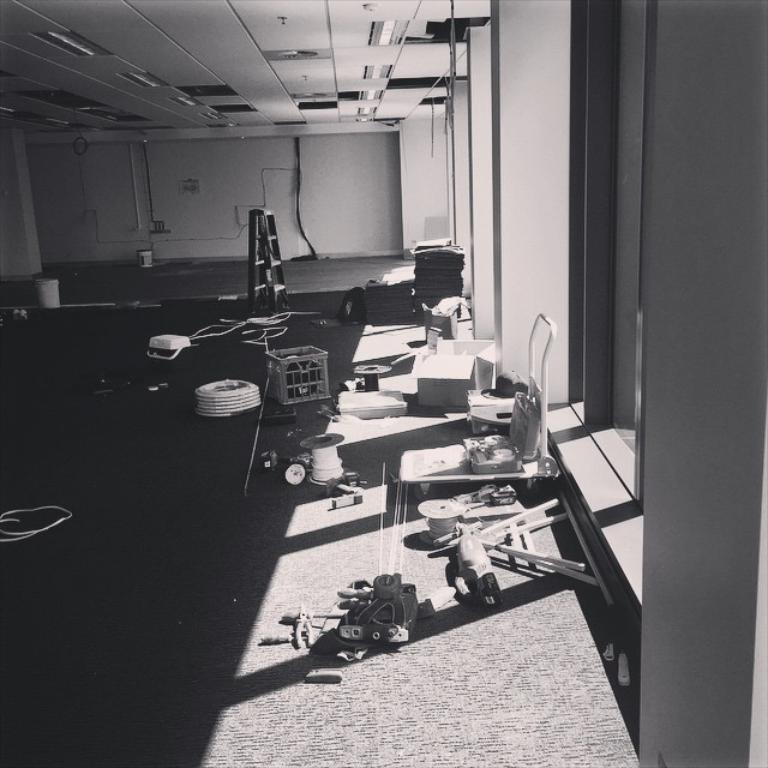What is placed on the floor in the image? There are objects placed on the floor in the image. Can you describe any other features related to the wall in the image? There is a wire attached to the wall in the image. What part of the room can be seen above the objects on the floor? There is a ceiling visible in the image. What type of stone can be seen on the floor in the image? There is no stone visible on the floor in the image; it is not mentioned in the provided facts. 